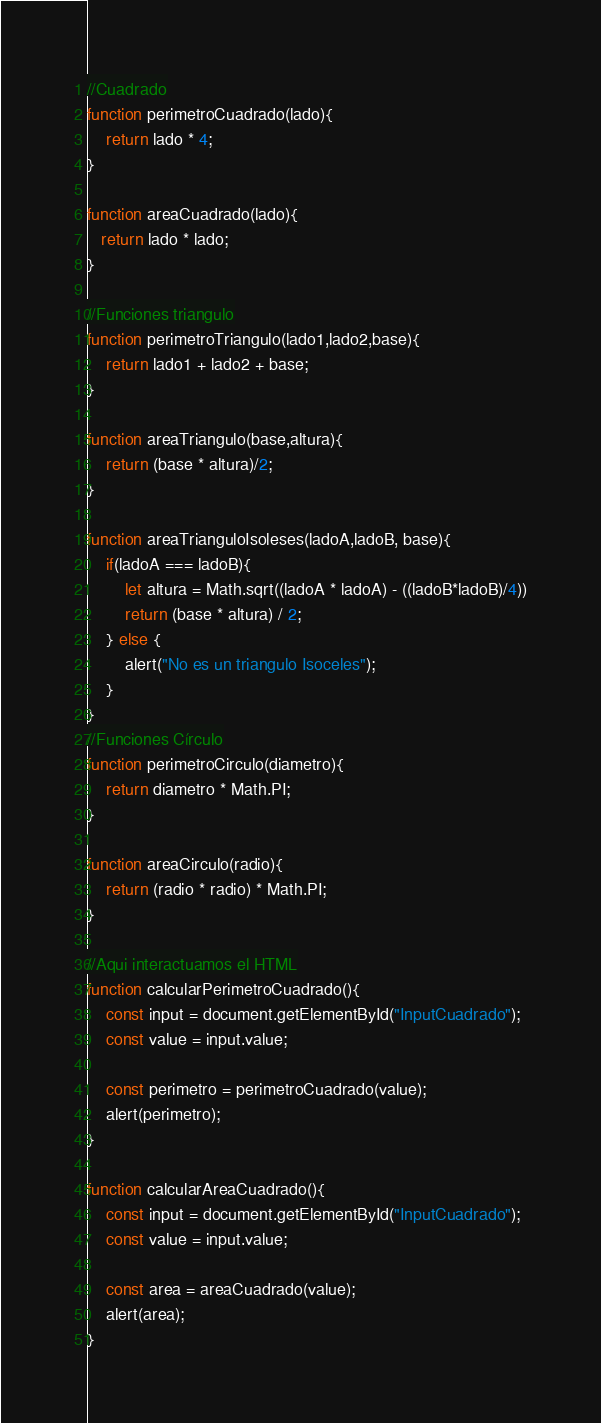<code> <loc_0><loc_0><loc_500><loc_500><_JavaScript_>//Cuadrado
function perimetroCuadrado(lado){
    return lado * 4;
}

function areaCuadrado(lado){
   return lado * lado;
}

//Funciones triangulo
function perimetroTriangulo(lado1,lado2,base){
    return lado1 + lado2 + base;
}

function areaTriangulo(base,altura){
    return (base * altura)/2;
}

function areaTrianguloIsoleses(ladoA,ladoB, base){
    if(ladoA === ladoB){
        let altura = Math.sqrt((ladoA * ladoA) - ((ladoB*ladoB)/4))
        return (base * altura) / 2;
    } else {
        alert("No es un triangulo Isoceles");
    }
}
//Funciones Círculo
function perimetroCirculo(diametro){
    return diametro * Math.PI;
}

function areaCirculo(radio){
    return (radio * radio) * Math.PI; 
}

//Aqui interactuamos el HTML
function calcularPerimetroCuadrado(){
    const input = document.getElementById("InputCuadrado");
    const value = input.value;

    const perimetro = perimetroCuadrado(value);
    alert(perimetro);
}

function calcularAreaCuadrado(){
    const input = document.getElementById("InputCuadrado");
    const value = input.value;

    const area = areaCuadrado(value);
    alert(area);
}</code> 